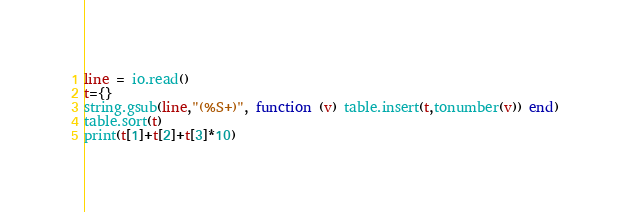Convert code to text. <code><loc_0><loc_0><loc_500><loc_500><_Lua_>line = io.read()
t={}
string.gsub(line,"(%S+)", function (v) table.insert(t,tonumber(v)) end)
table.sort(t)
print(t[1]+t[2]+t[3]*10)</code> 